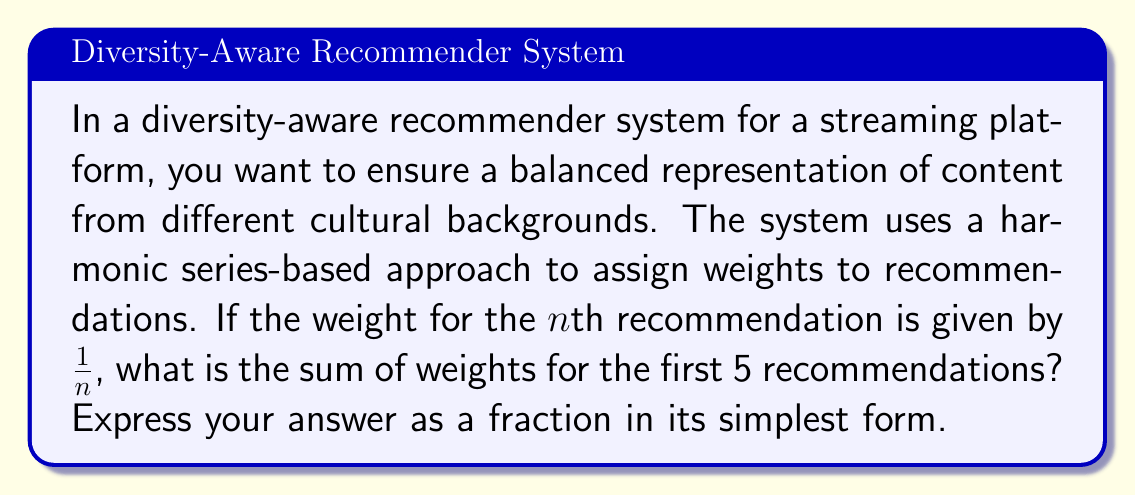Teach me how to tackle this problem. Let's approach this step-by-step:

1) The harmonic series is defined as:
   $$\sum_{n=1}^{\infty} \frac{1}{n} = 1 + \frac{1}{2} + \frac{1}{3} + \frac{1}{4} + ...$$

2) In this case, we're asked to find the sum of the first 5 terms:
   $$S = 1 + \frac{1}{2} + \frac{1}{3} + \frac{1}{4} + \frac{1}{5}$$

3) To add these fractions, we need a common denominator. The least common multiple of 1, 2, 3, 4, and 5 is 60.

4) Let's convert each fraction to an equivalent fraction with denominator 60:
   $$S = \frac{60}{60} + \frac{30}{60} + \frac{20}{60} + \frac{15}{60} + \frac{12}{60}$$

5) Now we can add the numerators:
   $$S = \frac{60 + 30 + 20 + 15 + 12}{60} = \frac{137}{60}$$

6) This fraction is already in its simplest form as 137 and 60 have no common factors other than 1.
Answer: $\frac{137}{60}$ 